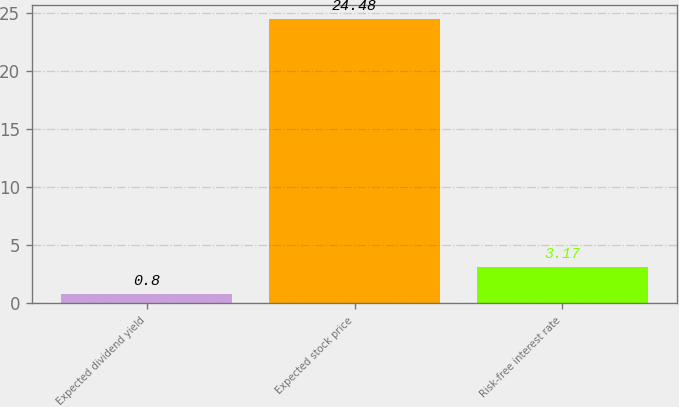Convert chart. <chart><loc_0><loc_0><loc_500><loc_500><bar_chart><fcel>Expected dividend yield<fcel>Expected stock price<fcel>Risk-free interest rate<nl><fcel>0.8<fcel>24.48<fcel>3.17<nl></chart> 